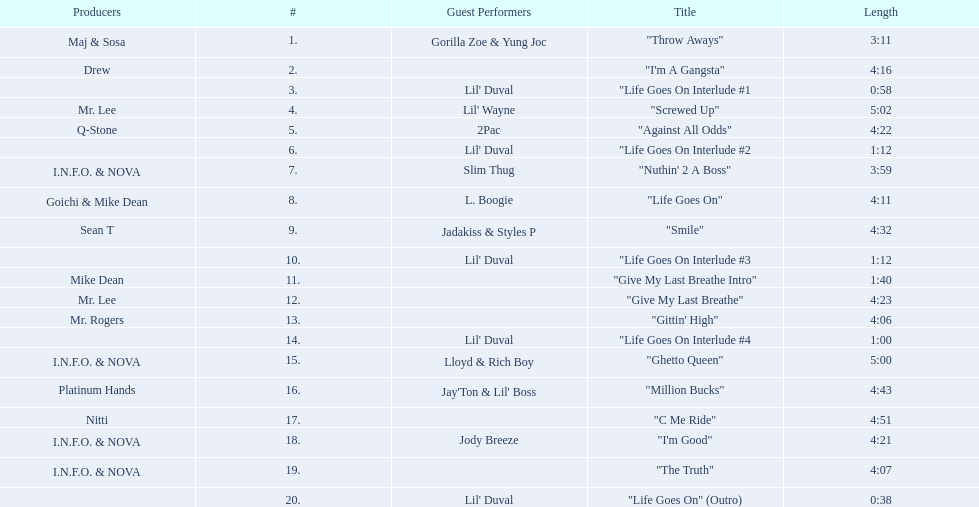What is the number of tracks featuring 2pac? 1. Parse the full table. {'header': ['Producers', '#', 'Guest Performers', 'Title', 'Length'], 'rows': [['Maj & Sosa', '1.', 'Gorilla Zoe & Yung Joc', '"Throw Aways"', '3:11'], ['Drew', '2.', '', '"I\'m A Gangsta"', '4:16'], ['', '3.', "Lil' Duval", '"Life Goes On Interlude #1', '0:58'], ['Mr. Lee', '4.', "Lil' Wayne", '"Screwed Up"', '5:02'], ['Q-Stone', '5.', '2Pac', '"Against All Odds"', '4:22'], ['', '6.', "Lil' Duval", '"Life Goes On Interlude #2', '1:12'], ['I.N.F.O. & NOVA', '7.', 'Slim Thug', '"Nuthin\' 2 A Boss"', '3:59'], ['Goichi & Mike Dean', '8.', 'L. Boogie', '"Life Goes On"', '4:11'], ['Sean T', '9.', 'Jadakiss & Styles P', '"Smile"', '4:32'], ['', '10.', "Lil' Duval", '"Life Goes On Interlude #3', '1:12'], ['Mike Dean', '11.', '', '"Give My Last Breathe Intro"', '1:40'], ['Mr. Lee', '12.', '', '"Give My Last Breathe"', '4:23'], ['Mr. Rogers', '13.', '', '"Gittin\' High"', '4:06'], ['', '14.', "Lil' Duval", '"Life Goes On Interlude #4', '1:00'], ['I.N.F.O. & NOVA', '15.', 'Lloyd & Rich Boy', '"Ghetto Queen"', '5:00'], ['Platinum Hands', '16.', "Jay'Ton & Lil' Boss", '"Million Bucks"', '4:43'], ['Nitti', '17.', '', '"C Me Ride"', '4:51'], ['I.N.F.O. & NOVA', '18.', 'Jody Breeze', '"I\'m Good"', '4:21'], ['I.N.F.O. & NOVA', '19.', '', '"The Truth"', '4:07'], ['', '20.', "Lil' Duval", '"Life Goes On" (Outro)', '0:38']]} 